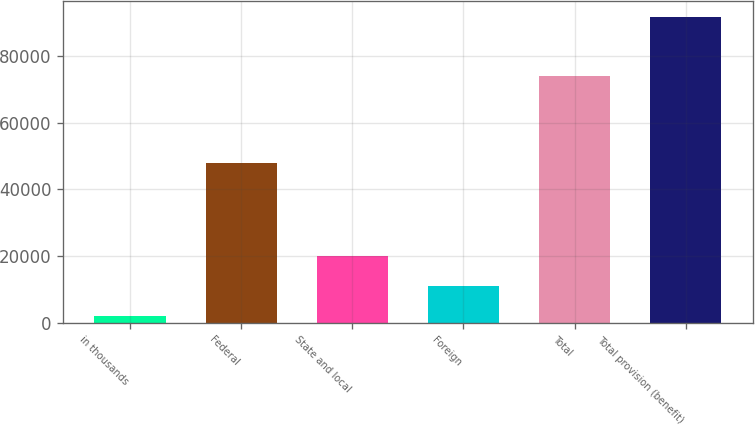Convert chart. <chart><loc_0><loc_0><loc_500><loc_500><bar_chart><fcel>in thousands<fcel>Federal<fcel>State and local<fcel>Foreign<fcel>Total<fcel>Total provision (benefit)<nl><fcel>2014<fcel>47882<fcel>19949.6<fcel>10981.8<fcel>74039<fcel>91692<nl></chart> 